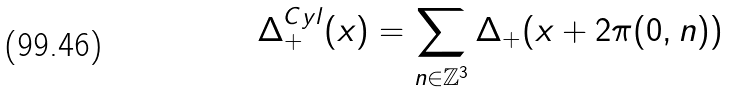Convert formula to latex. <formula><loc_0><loc_0><loc_500><loc_500>\Delta _ { + } ^ { C y l } ( x ) = \sum _ { n \in \mathbb { Z } ^ { 3 } } \Delta _ { + } ( x + 2 \pi ( 0 , n ) )</formula> 